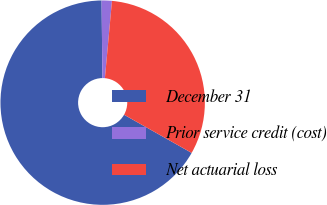Convert chart to OTSL. <chart><loc_0><loc_0><loc_500><loc_500><pie_chart><fcel>December 31<fcel>Prior service credit (cost)<fcel>Net actuarial loss<nl><fcel>66.64%<fcel>1.62%<fcel>31.73%<nl></chart> 